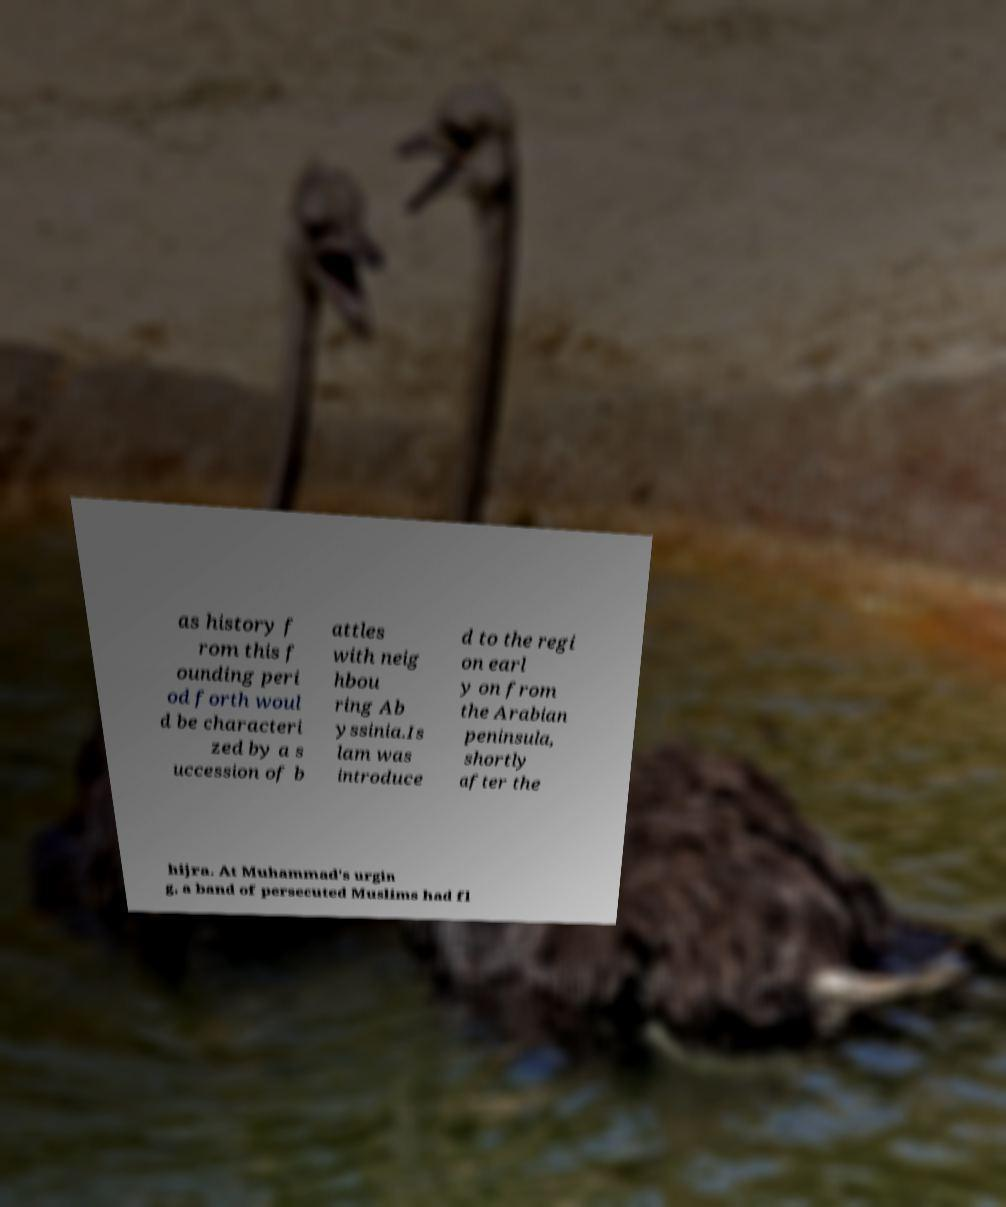What messages or text are displayed in this image? I need them in a readable, typed format. as history f rom this f ounding peri od forth woul d be characteri zed by a s uccession of b attles with neig hbou ring Ab yssinia.Is lam was introduce d to the regi on earl y on from the Arabian peninsula, shortly after the hijra. At Muhammad's urgin g, a band of persecuted Muslims had fl 